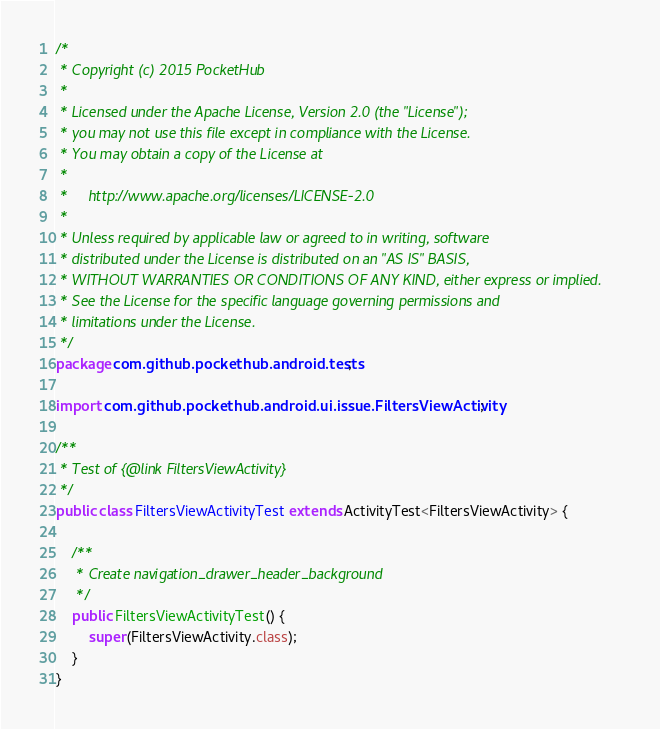Convert code to text. <code><loc_0><loc_0><loc_500><loc_500><_Java_>/*
 * Copyright (c) 2015 PocketHub
 *
 * Licensed under the Apache License, Version 2.0 (the "License");
 * you may not use this file except in compliance with the License.
 * You may obtain a copy of the License at
 *
 *     http://www.apache.org/licenses/LICENSE-2.0
 *
 * Unless required by applicable law or agreed to in writing, software
 * distributed under the License is distributed on an "AS IS" BASIS,
 * WITHOUT WARRANTIES OR CONDITIONS OF ANY KIND, either express or implied.
 * See the License for the specific language governing permissions and
 * limitations under the License.
 */
package com.github.pockethub.android.tests;

import com.github.pockethub.android.ui.issue.FiltersViewActivity;

/**
 * Test of {@link FiltersViewActivity}
 */
public class FiltersViewActivityTest extends ActivityTest<FiltersViewActivity> {

    /**
     * Create navigation_drawer_header_background
     */
    public FiltersViewActivityTest() {
        super(FiltersViewActivity.class);
    }
}
</code> 